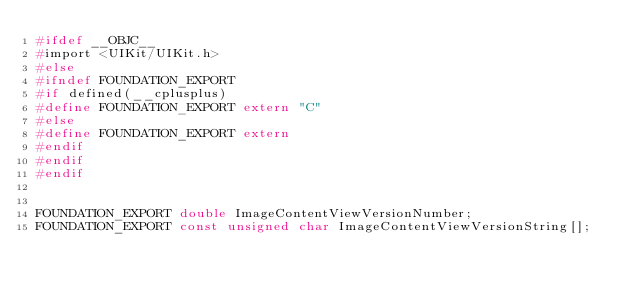<code> <loc_0><loc_0><loc_500><loc_500><_C_>#ifdef __OBJC__
#import <UIKit/UIKit.h>
#else
#ifndef FOUNDATION_EXPORT
#if defined(__cplusplus)
#define FOUNDATION_EXPORT extern "C"
#else
#define FOUNDATION_EXPORT extern
#endif
#endif
#endif


FOUNDATION_EXPORT double ImageContentViewVersionNumber;
FOUNDATION_EXPORT const unsigned char ImageContentViewVersionString[];

</code> 